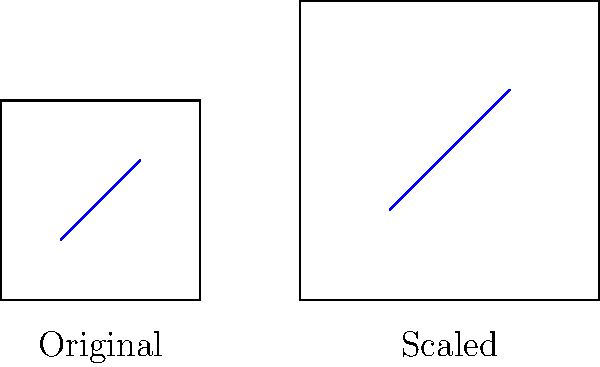A player's shooting range diagram is represented by a square with side length 100 units, with their average shooting distance marked by a blue line from (30,30) to (70,70). To analyze performance improvements, the diagram is scaled by a factor of 1.5. What are the coordinates of the endpoints of the blue line in the scaled diagram? To solve this problem, we need to apply the scaling factor to the original coordinates:

1. Original coordinates of the blue line:
   Start point: (30, 30)
   End point: (70, 70)

2. Scaling factor: 1.5

3. To scale a point (x, y) by a factor k, we multiply both coordinates by k:
   New x = k * x
   New y = k * y

4. For the start point (30, 30):
   New x = 1.5 * 30 = 45
   New y = 1.5 * 30 = 45
   New start point: (45, 45)

5. For the end point (70, 70):
   New x = 1.5 * 70 = 105
   New y = 1.5 * 70 = 105
   New end point: (105, 105)

6. The scaled blue line now goes from (45, 45) to (105, 105)
Answer: (45, 45) and (105, 105) 